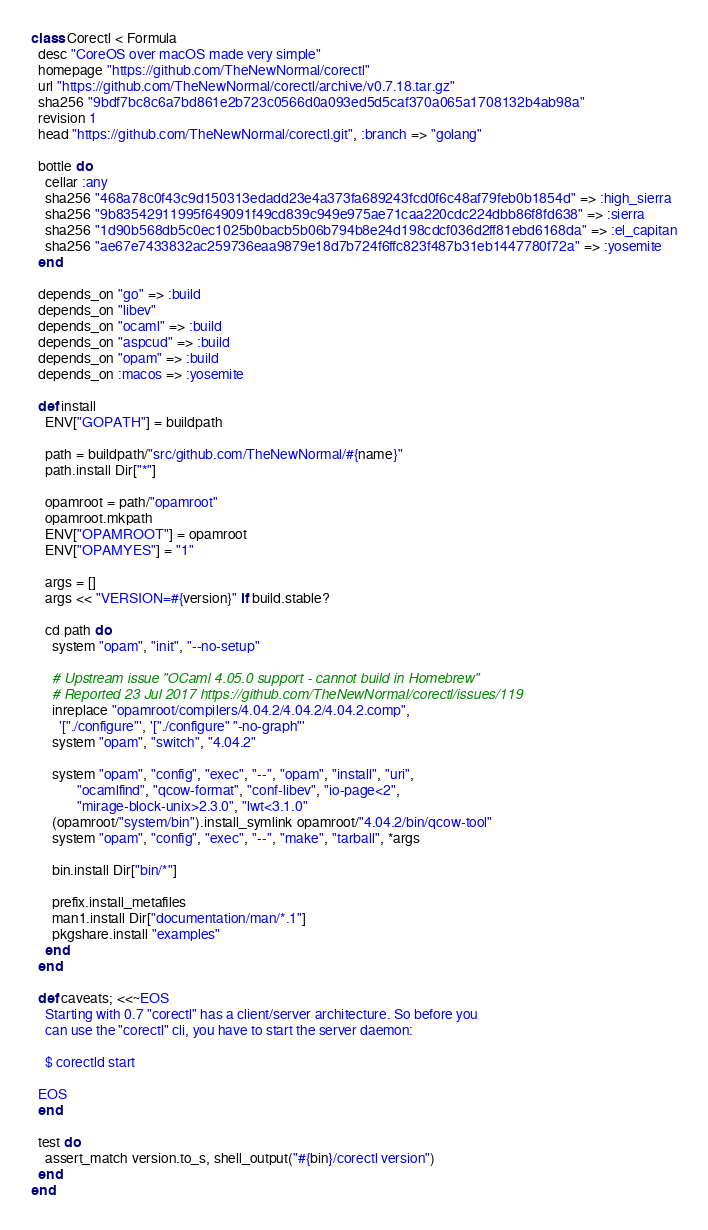Convert code to text. <code><loc_0><loc_0><loc_500><loc_500><_Ruby_>class Corectl < Formula
  desc "CoreOS over macOS made very simple"
  homepage "https://github.com/TheNewNormal/corectl"
  url "https://github.com/TheNewNormal/corectl/archive/v0.7.18.tar.gz"
  sha256 "9bdf7bc8c6a7bd861e2b723c0566d0a093ed5d5caf370a065a1708132b4ab98a"
  revision 1
  head "https://github.com/TheNewNormal/corectl.git", :branch => "golang"

  bottle do
    cellar :any
    sha256 "468a78c0f43c9d150313edadd23e4a373fa689243fcd0f6c48af79feb0b1854d" => :high_sierra
    sha256 "9b83542911995f649091f49cd839c949e975ae71caa220cdc224dbb86f8fd638" => :sierra
    sha256 "1d90b568db5c0ec1025b0bacb5b06b794b8e24d198cdcf036d2ff81ebd6168da" => :el_capitan
    sha256 "ae67e7433832ac259736eaa9879e18d7b724f6ffc823f487b31eb1447780f72a" => :yosemite
  end

  depends_on "go" => :build
  depends_on "libev"
  depends_on "ocaml" => :build
  depends_on "aspcud" => :build
  depends_on "opam" => :build
  depends_on :macos => :yosemite

  def install
    ENV["GOPATH"] = buildpath

    path = buildpath/"src/github.com/TheNewNormal/#{name}"
    path.install Dir["*"]

    opamroot = path/"opamroot"
    opamroot.mkpath
    ENV["OPAMROOT"] = opamroot
    ENV["OPAMYES"] = "1"

    args = []
    args << "VERSION=#{version}" if build.stable?

    cd path do
      system "opam", "init", "--no-setup"

      # Upstream issue "OCaml 4.05.0 support - cannot build in Homebrew"
      # Reported 23 Jul 2017 https://github.com/TheNewNormal/corectl/issues/119
      inreplace "opamroot/compilers/4.04.2/4.04.2/4.04.2.comp",
        '["./configure"', '["./configure" "-no-graph"'
      system "opam", "switch", "4.04.2"

      system "opam", "config", "exec", "--", "opam", "install", "uri",
             "ocamlfind", "qcow-format", "conf-libev", "io-page<2",
             "mirage-block-unix>2.3.0", "lwt<3.1.0"
      (opamroot/"system/bin").install_symlink opamroot/"4.04.2/bin/qcow-tool"
      system "opam", "config", "exec", "--", "make", "tarball", *args

      bin.install Dir["bin/*"]

      prefix.install_metafiles
      man1.install Dir["documentation/man/*.1"]
      pkgshare.install "examples"
    end
  end

  def caveats; <<~EOS
    Starting with 0.7 "corectl" has a client/server architecture. So before you
    can use the "corectl" cli, you have to start the server daemon:

    $ corectld start

  EOS
  end

  test do
    assert_match version.to_s, shell_output("#{bin}/corectl version")
  end
end
</code> 